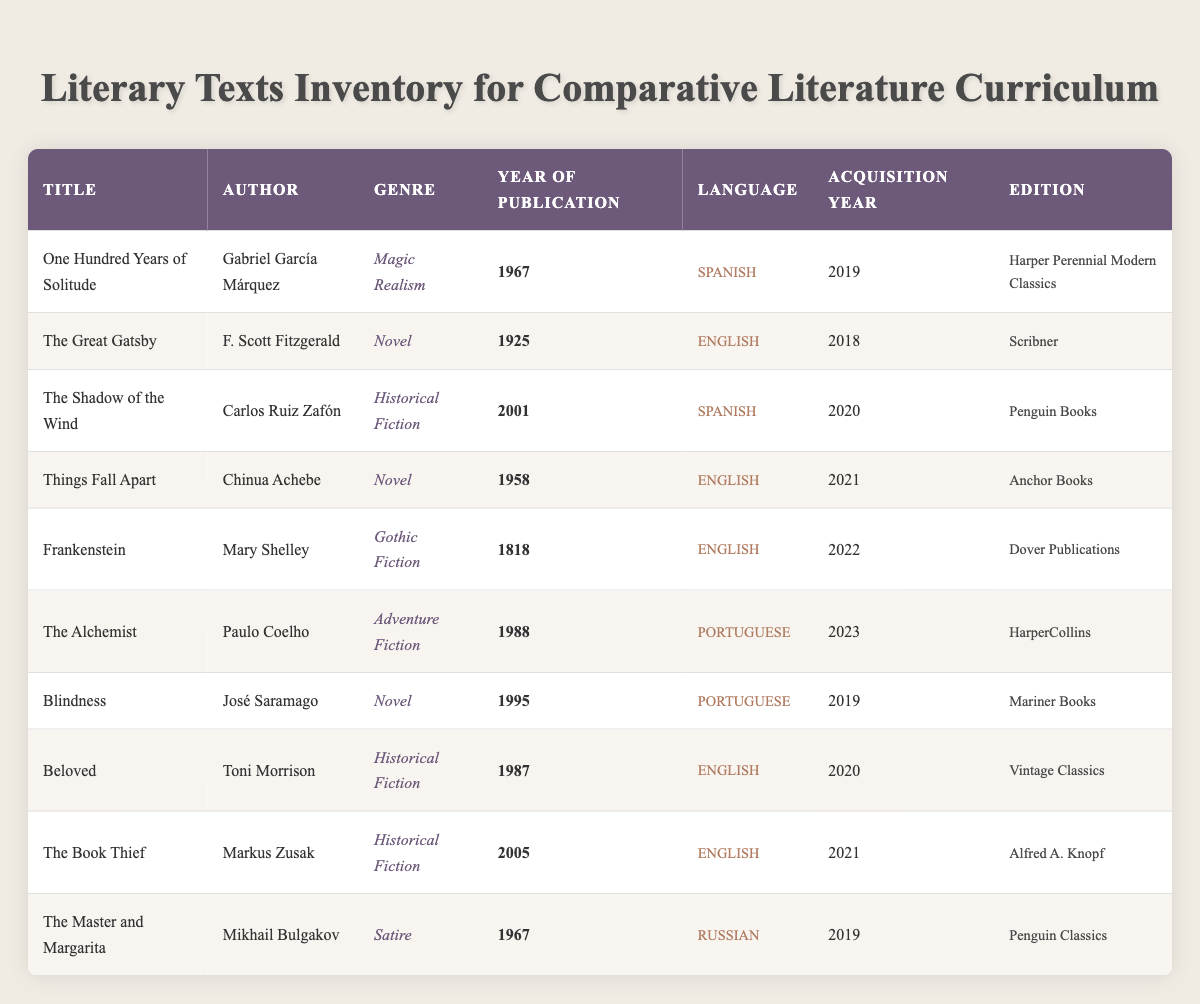What is the title of the oldest book in the inventory? The oldest book in the inventory is determined by checking the "Year of Publication" column. The earliest year listed is 1818 for "Frankenstein."
Answer: Frankenstein Which language is the most represented in the inventory? To determine the most represented language, we count the occurrences of each language in the "Language" column. Spanish and English both appear most frequently, each with four occurrences.
Answer: Spanish and English How many books were acquired in the year 2020? By referring to the "Acquisition Year" column, we count the entries for the year 2020. The entries for "The Shadow of the Wind," "Beloved," and "The Alchemist" sum to three books.
Answer: 3 Is "The Great Gatsby" the only English-language novel acquired in the last five years? Checking the language and acquisition year in the table, we find that "The Great Gatsby" is not the only English-language novel, as "Things Fall Apart," "Frankenstein," "Blindness," "Beloved," and "The Book Thief" are also in English.
Answer: No What is the average year of publication for the books acquired in 2021? Focusing on the "Year of Publication" for books acquired in 2021 — "Things Fall Apart" (1958), "The Book Thief" (2005) — we calculate the average: (1958 + 2005) / 2 = 1981.5.
Answer: 1981.5 Which author has written books in more than one language? We analyze the "Author" column. Only Paulo Coelho's "The Alchemist" (Portuguese) and Gabriel García Márquez's "One Hundred Years of Solitude" (Spanish) will indicate books in different languages. Therefore, Paulo Coelho is the only one in this case.
Answer: No How many genres are represented in the inventory? We list the unique genres in the "Genre" column: Magic Realism, Novel, Historical Fiction, Gothic Fiction, Adventure Fiction, and Satire. There are a total of six distinct genres.
Answer: 6 Which book was acquired most recently? The "Acquisition Year" column indicates that "The Alchemist" was acquired in 2023, which is the most recent year listed.
Answer: The Alchemist How many books are authored by women? We check the "Author" column for books by female authors. "Frankenstein" (Mary Shelley), "Beloved" (Toni Morrison), and "The Book Thief" (Markus Zusak). Thus,  The total is three.
Answer: 3 